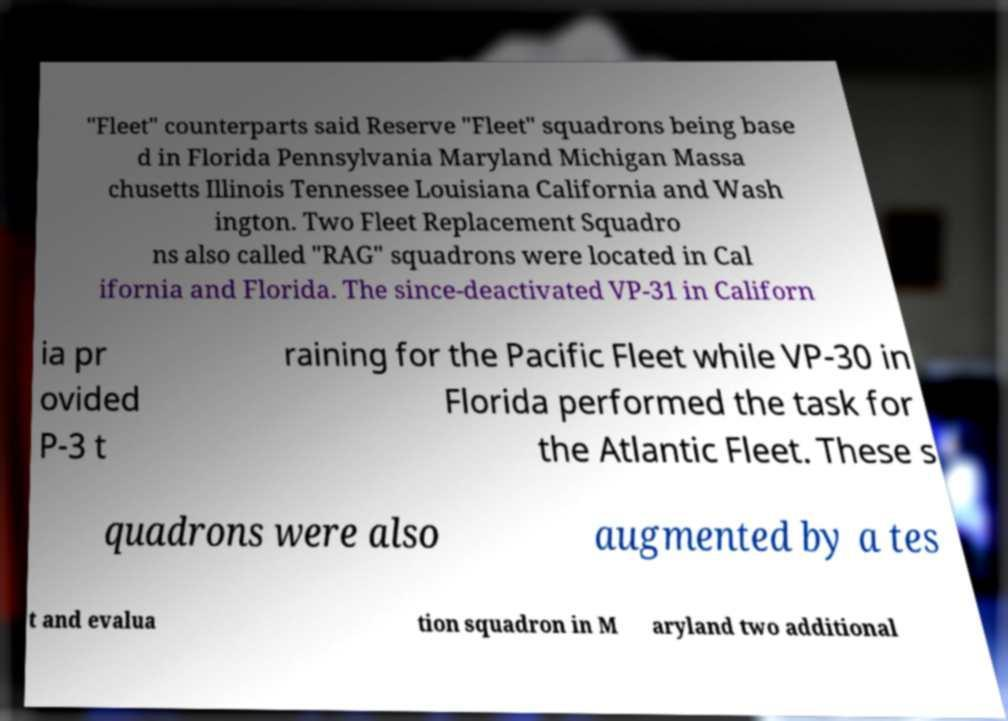I need the written content from this picture converted into text. Can you do that? "Fleet" counterparts said Reserve "Fleet" squadrons being base d in Florida Pennsylvania Maryland Michigan Massa chusetts Illinois Tennessee Louisiana California and Wash ington. Two Fleet Replacement Squadro ns also called "RAG" squadrons were located in Cal ifornia and Florida. The since-deactivated VP-31 in Californ ia pr ovided P-3 t raining for the Pacific Fleet while VP-30 in Florida performed the task for the Atlantic Fleet. These s quadrons were also augmented by a tes t and evalua tion squadron in M aryland two additional 